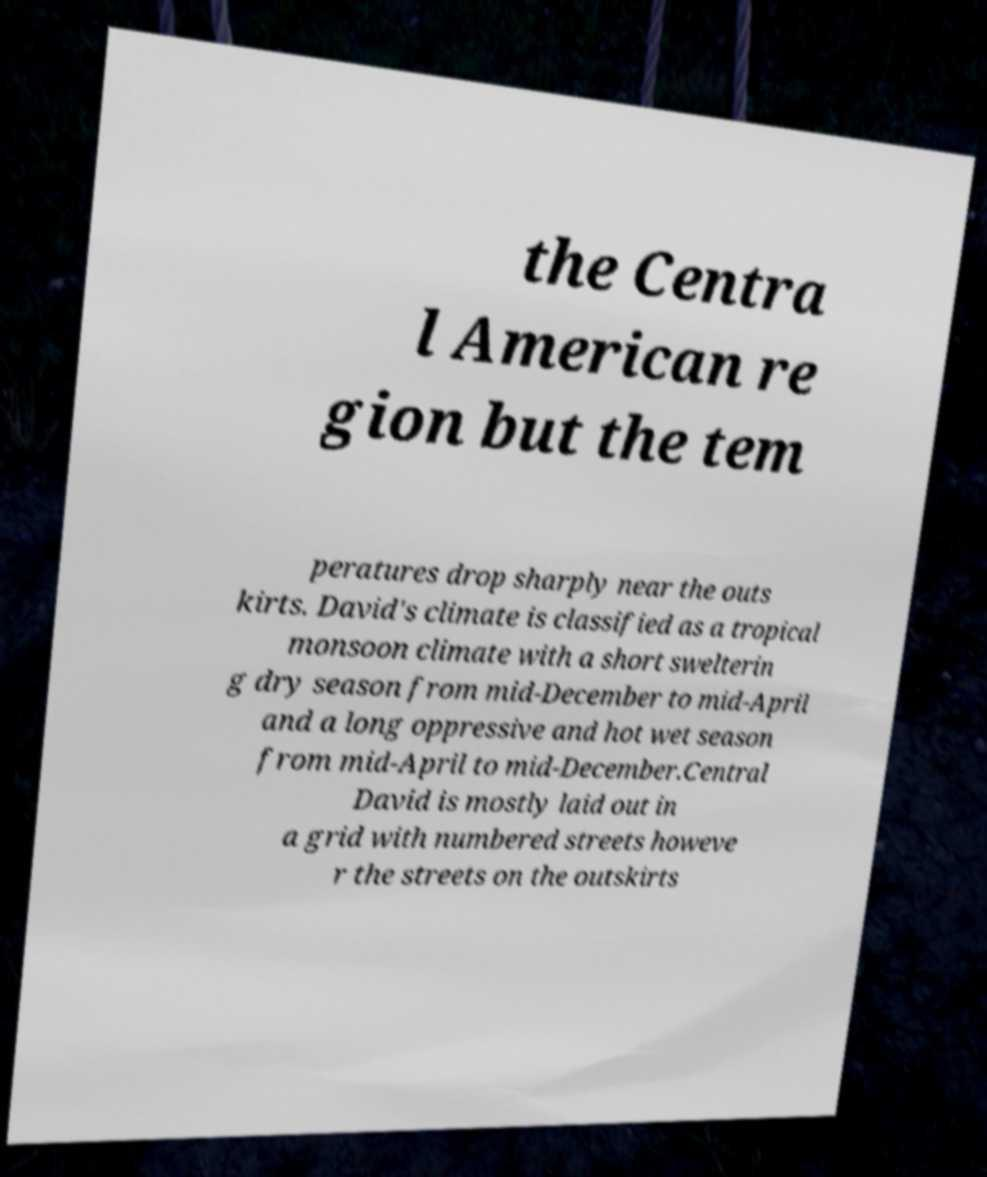I need the written content from this picture converted into text. Can you do that? the Centra l American re gion but the tem peratures drop sharply near the outs kirts. David's climate is classified as a tropical monsoon climate with a short swelterin g dry season from mid-December to mid-April and a long oppressive and hot wet season from mid-April to mid-December.Central David is mostly laid out in a grid with numbered streets howeve r the streets on the outskirts 